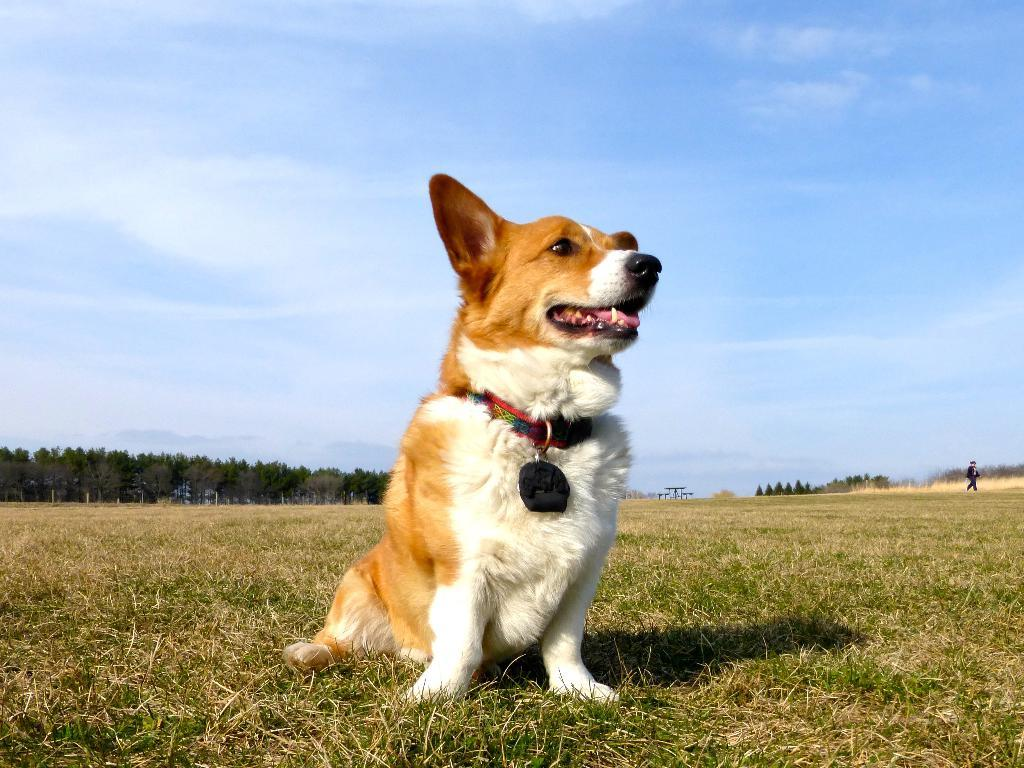What animal can be seen in the image? There is a dog in the image. What is the dog doing in the image? The dog is sitting on the ground. What can be seen in the background of the image? There are trees in the background of the image. What is visible at the top of the image? The sky is visible at the top of the image. What type of wound can be seen on the dog's paw in the image? There is no wound visible on the dog's paw in the image. What type of liquid is being served in a bowl next to the dog in the image? There is no bowl or liquid present in the image; it only features a dog sitting on the ground. 